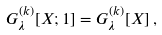<formula> <loc_0><loc_0><loc_500><loc_500>G _ { \lambda } ^ { ( k ) } [ X ; 1 ] = G _ { \lambda } ^ { ( k ) } [ X ] \, ,</formula> 